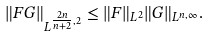<formula> <loc_0><loc_0><loc_500><loc_500>\| F G \| _ { L ^ { \frac { 2 n } { n + 2 } , 2 } } \leq \| F \| _ { L ^ { 2 } } \| G \| _ { L ^ { n , \infty } } .</formula> 